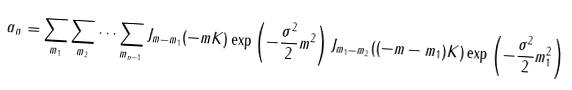<formula> <loc_0><loc_0><loc_500><loc_500>a _ { n } = \sum _ { m _ { 1 } } \sum _ { m _ { 2 } } \dots \sum _ { m _ { n - 1 } } J _ { m - m _ { 1 } } ( - m K ) \exp \left ( - \frac { \sigma ^ { 2 } } { 2 } m ^ { 2 } \right ) J _ { m _ { 1 } - m _ { 2 } } ( ( - m - m _ { 1 } ) K ) \exp \left ( - \frac { \sigma ^ { 2 } } { 2 } m _ { 1 } ^ { 2 } \right )</formula> 